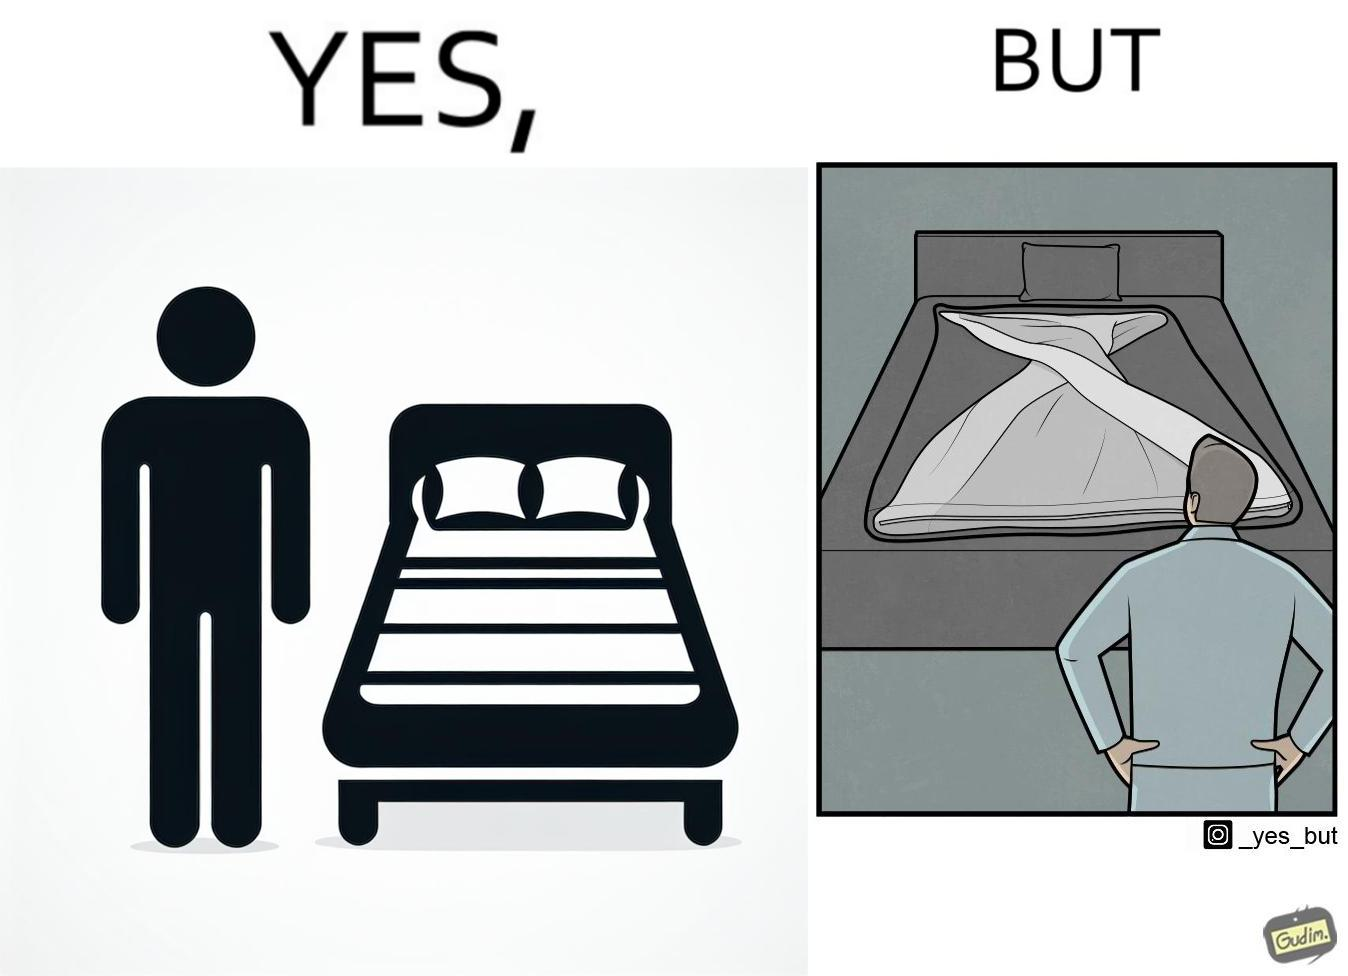Is there satirical content in this image? Yes, this image is satirical. 